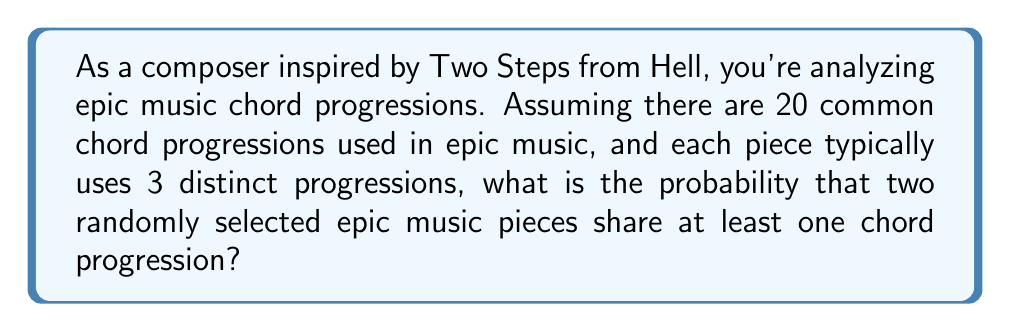Teach me how to tackle this problem. Let's approach this step-by-step:

1) First, we need to calculate the probability that the two pieces don't share any chord progressions.

2) Each piece uses 3 out of 20 possible progressions. For the first piece, there are $\binom{20}{3}$ ways to choose 3 progressions.

3) For the second piece to not share any progressions with the first, it must choose 3 from the remaining 17 progressions. This can be done in $\binom{17}{3}$ ways.

4) The total number of ways to choose progressions for both pieces is $\binom{20}{3} \cdot \binom{20}{3}$, as each piece chooses independently from all 20 progressions.

5) Therefore, the probability of no shared progressions is:

   $$P(\text{no shared}) = \frac{\binom{20}{3} \cdot \binom{17}{3}}{\binom{20}{3} \cdot \binom{20}{3}}$$

6) Simplify:
   $$P(\text{no shared}) = \frac{\binom{17}{3}}{\binom{20}{3}} = \frac{17 \cdot 16 \cdot 15}{20 \cdot 19 \cdot 18} = 0.5025$$

7) The probability of sharing at least one progression is the complement of this:

   $$P(\text{shared}) = 1 - P(\text{no shared}) = 1 - 0.5025 = 0.4975$$

8) Convert to a percentage: 0.4975 * 100 = 49.75%
Answer: 49.75% 